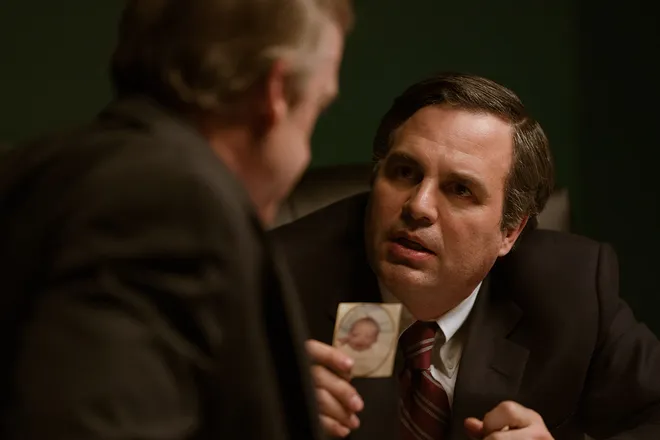What are the key elements in this picture? The image shows two men engaged in a close discussion. The man in the foreground, displaying a concerned expression, is attentively listening or perhaps making an argument to the other individual, who is holding a photograph. Both men are in professional attire, suggesting a formal setting or event. There's tension conveyed by their expressions and proximity, indicative of a serious and possibly confrontational conversation. The lighting is subdued with a greenish tint, adding to a somber ambiance. 